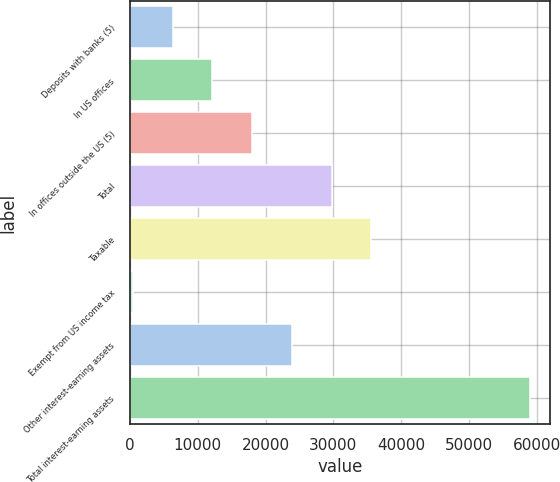Convert chart to OTSL. <chart><loc_0><loc_0><loc_500><loc_500><bar_chart><fcel>Deposits with banks (5)<fcel>In US offices<fcel>In offices outside the US (5)<fcel>Total<fcel>Taxable<fcel>Exempt from US income tax<fcel>Other interest-earning assets<fcel>Total interest-earning assets<nl><fcel>6302.7<fcel>12162.4<fcel>18022.1<fcel>29741.5<fcel>35601.2<fcel>443<fcel>23881.8<fcel>59040<nl></chart> 